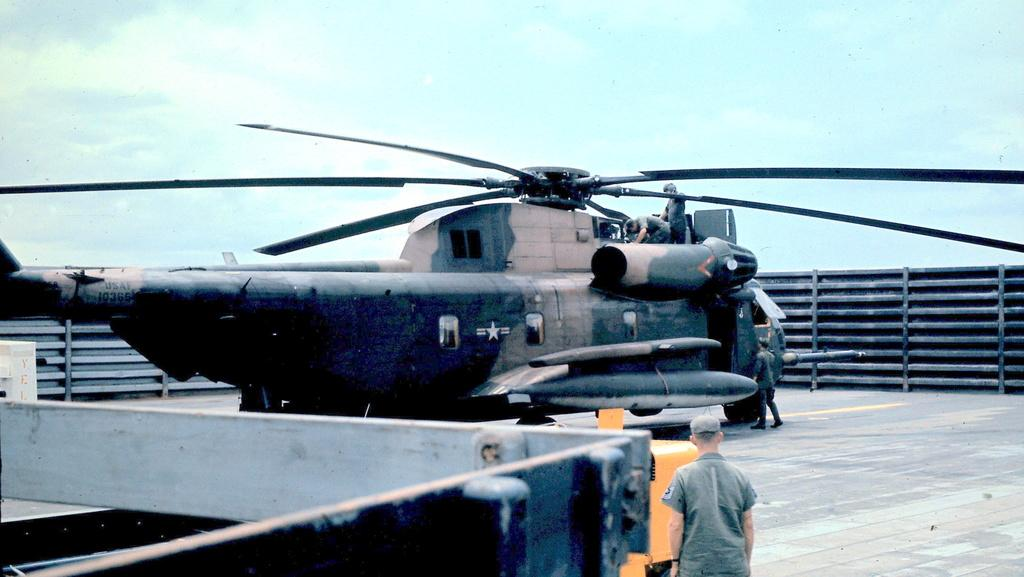What is the main subject of the picture? The main subject of the picture is a plane. Is there anyone on the plane? Yes, there is a person on the plane. What can be seen around the plane? There is fencing around the plane, and there are people around it. Can you see any cribs or crayons in the picture? No, there are no cribs or crayons present in the image. Are there any bears visible in the picture? No, there are no bears visible in the image. 